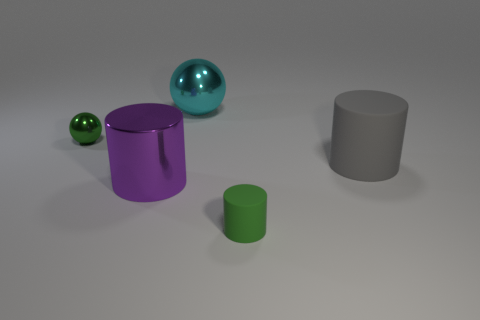Add 3 large purple cylinders. How many objects exist? 8 Subtract all cylinders. How many objects are left? 2 Add 5 small yellow shiny blocks. How many small yellow shiny blocks exist? 5 Subtract 0 purple cubes. How many objects are left? 5 Subtract all big cyan metallic balls. Subtract all matte cylinders. How many objects are left? 2 Add 2 green metallic balls. How many green metallic balls are left? 3 